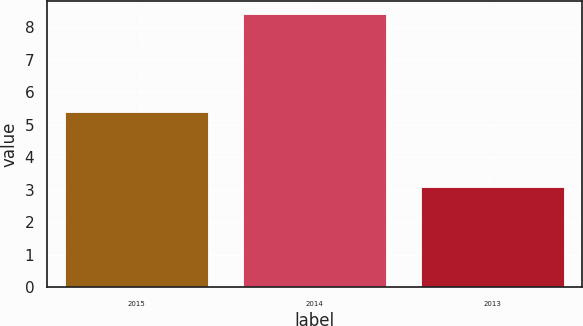<chart> <loc_0><loc_0><loc_500><loc_500><bar_chart><fcel>2015<fcel>2014<fcel>2013<nl><fcel>5.4<fcel>8.4<fcel>3.1<nl></chart> 